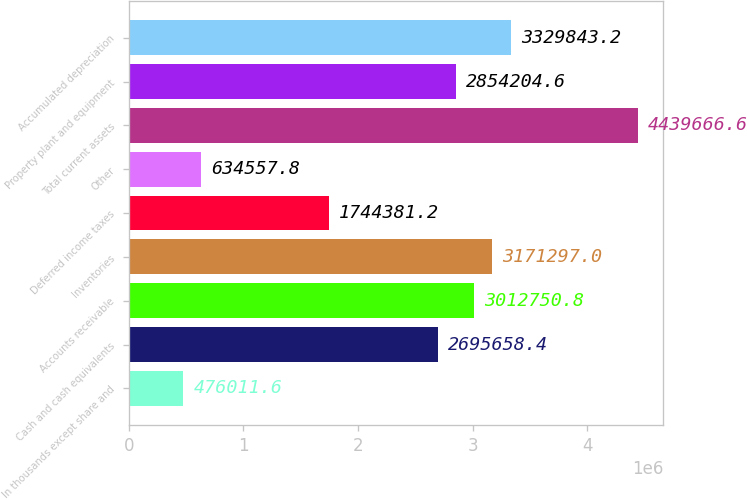Convert chart. <chart><loc_0><loc_0><loc_500><loc_500><bar_chart><fcel>In thousands except share and<fcel>Cash and cash equivalents<fcel>Accounts receivable<fcel>Inventories<fcel>Deferred income taxes<fcel>Other<fcel>Total current assets<fcel>Property plant and equipment<fcel>Accumulated depreciation<nl><fcel>476012<fcel>2.69566e+06<fcel>3.01275e+06<fcel>3.1713e+06<fcel>1.74438e+06<fcel>634558<fcel>4.43967e+06<fcel>2.8542e+06<fcel>3.32984e+06<nl></chart> 